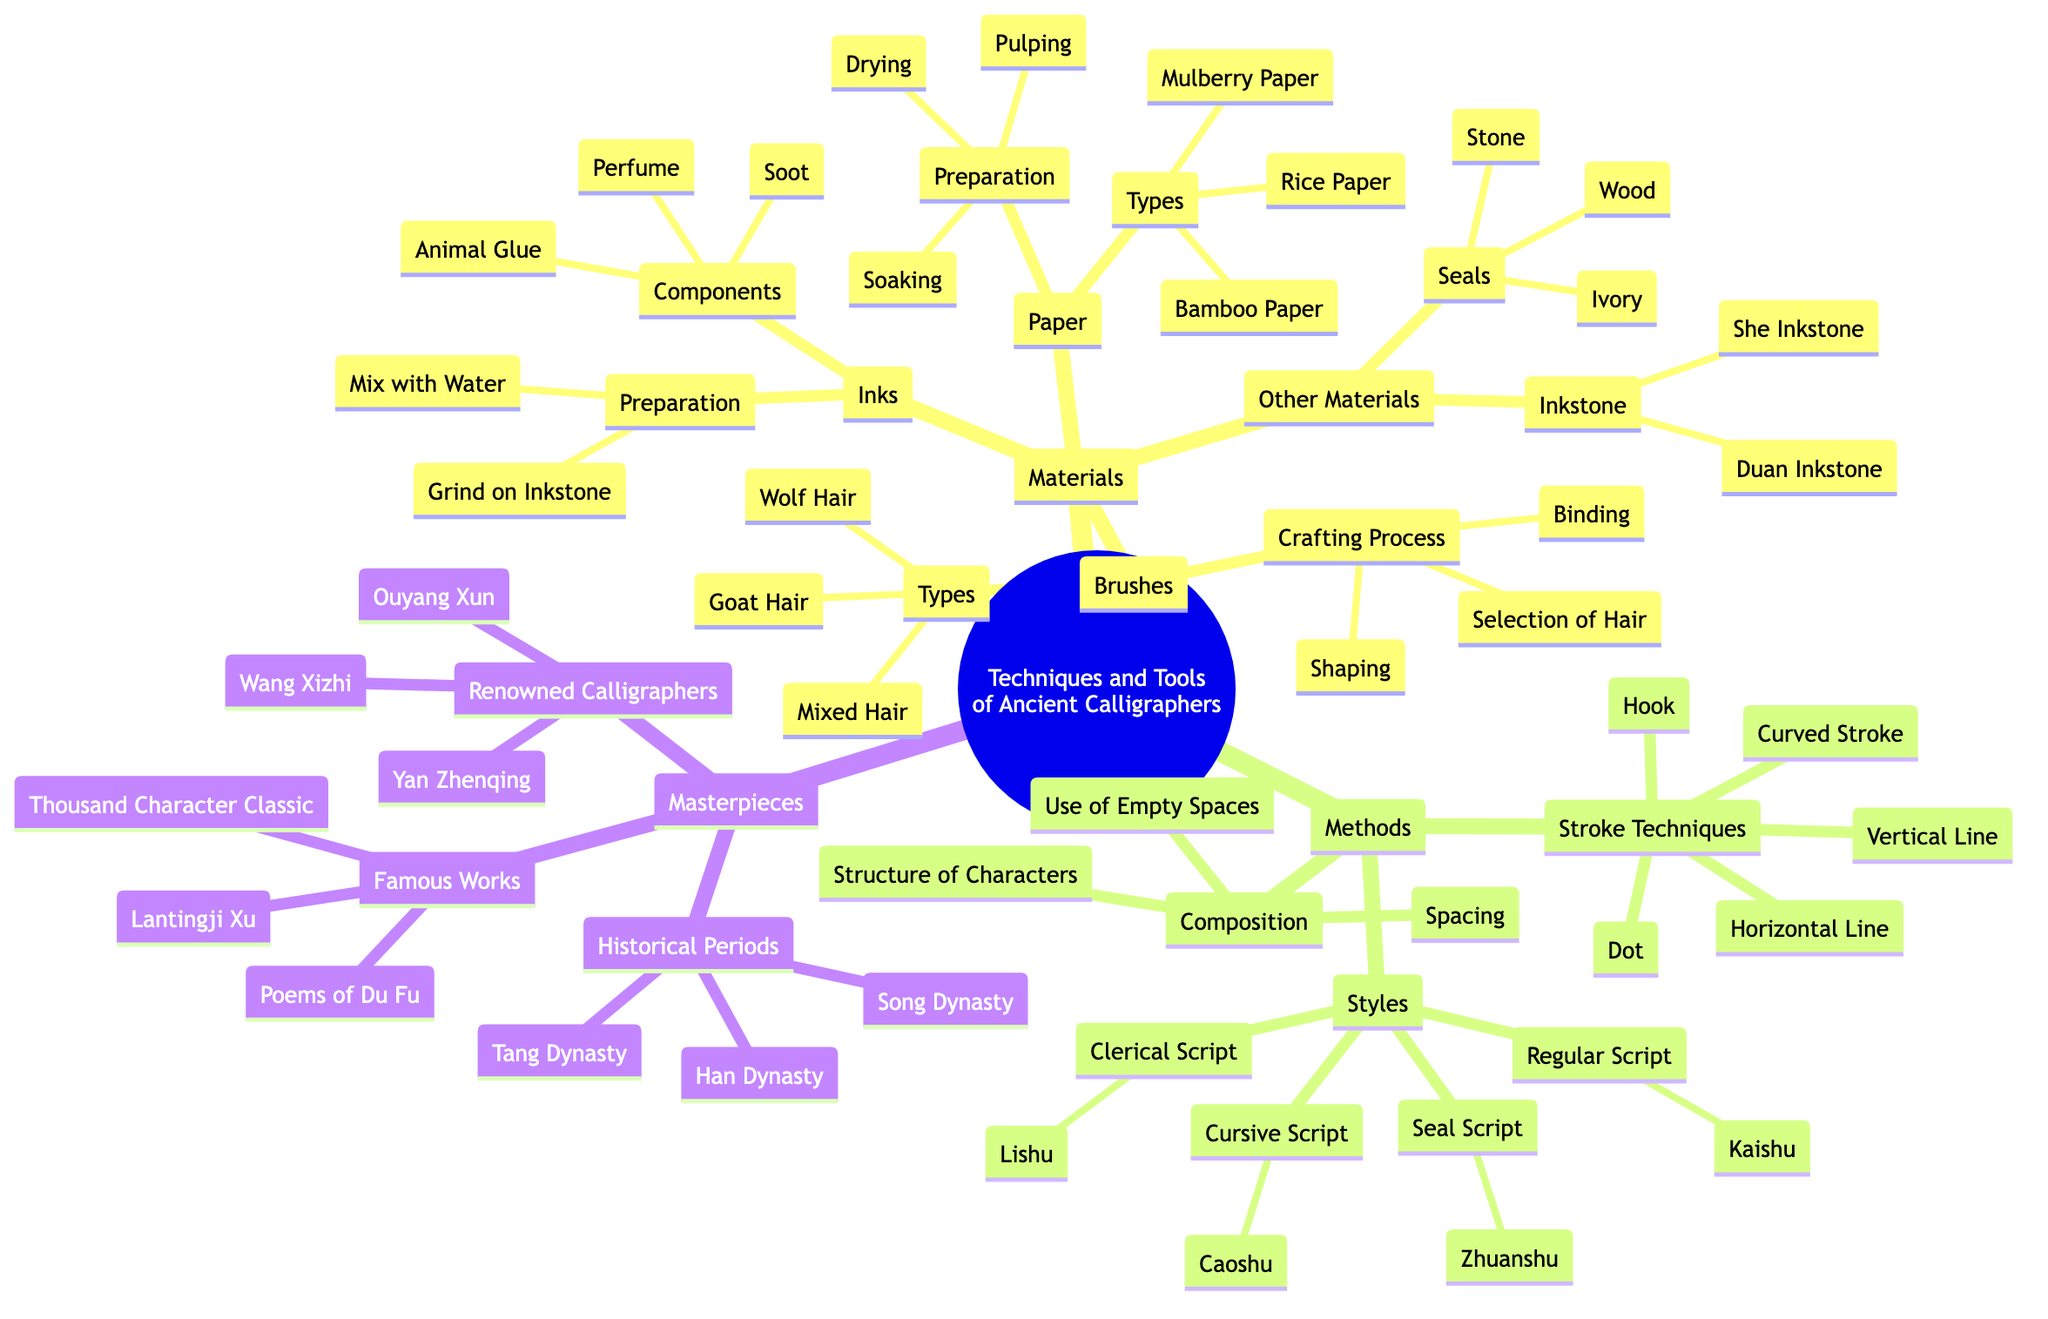What are the types of brushes used by ancient calligraphers? The diagram indicates that the types of brushes are Wolf Hair Brushes, Goat Hair Brushes, and Mixed Hair Brushes, which are all listed under the Brushes section of Materials.
Answer: Wolf Hair Brushes, Goat Hair Brushes, Mixed Hair Brushes What are the components of the inks used? According to the diagram, the components of inks include Soot, Animal Glue, and Perfume, as stated under the Inks section.
Answer: Soot, Animal Glue, Perfume How many styles of calligraphy are mentioned in the diagram? The diagram lists four styles of calligraphy: Regular Script, Cursive Script, Clerical Script, and Seal Script. Thus, there are a total of four styles.
Answer: 4 Which historical periods are represented in the Masterpieces section? The diagram specifies three historical periods: Han Dynasty, Tang Dynasty, and Song Dynasty, found in the Masterpieces section under Historical Periods.
Answer: Han Dynasty, Tang Dynasty, Song Dynasty What is the crafting process for brushes according to the diagram? The crafting process for brushes includes Selection of Hair, Binding, and Shaping, which are detailed in the Brushes section under Crafting Process.
Answer: Selection of Hair, Binding, Shaping What stroke technique is not mentioned in the diagram? The stroke techniques listed include Dot, Horizontal Line, Vertical Line, Hook, and Curved Stroke. Therefore, any stroke technique not matching these five counts as not mentioned, like "Spiral."
Answer: Spiral How do the types of paper used differ in preparation? The preparation methods for the types of paper, which are Soaking, Pulping, and Drying, are part of the Paper section. All three types of paper share these same preparation steps, which need to be differentiated by each type.
Answer: Soaking, Pulping, Drying Who is the renowned calligrapher associated with Cursive Script? The diagram connects Caoshu with the category 'Cursive Script' and lists the renowned calligraphers within the Masterpieces section. As Caoshu is labeled as a style under Methods, it can be judged indirectly that a renowned calligrapher like Wang Xizhi is associated as he is famous for this style.
Answer: Wang Xizhi 